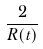Convert formula to latex. <formula><loc_0><loc_0><loc_500><loc_500>\frac { 2 } { R ( t ) }</formula> 